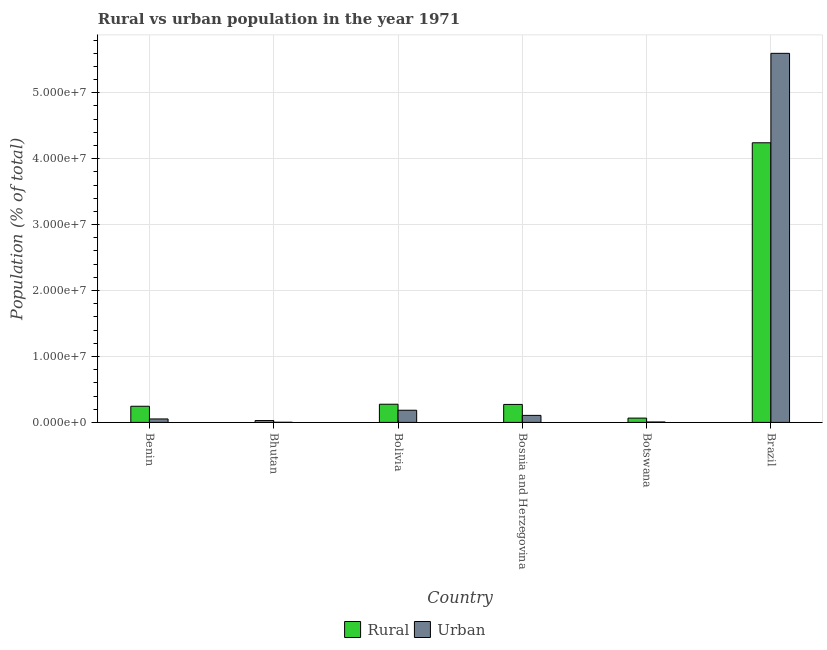How many groups of bars are there?
Your answer should be very brief. 6. Are the number of bars per tick equal to the number of legend labels?
Your response must be concise. Yes. Are the number of bars on each tick of the X-axis equal?
Keep it short and to the point. Yes. How many bars are there on the 1st tick from the left?
Offer a terse response. 2. How many bars are there on the 2nd tick from the right?
Keep it short and to the point. 2. What is the label of the 2nd group of bars from the left?
Provide a short and direct response. Bhutan. In how many cases, is the number of bars for a given country not equal to the number of legend labels?
Offer a very short reply. 0. What is the rural population density in Bosnia and Herzegovina?
Make the answer very short. 2.73e+06. Across all countries, what is the maximum rural population density?
Offer a terse response. 4.24e+07. Across all countries, what is the minimum rural population density?
Your answer should be compact. 2.82e+05. In which country was the urban population density minimum?
Ensure brevity in your answer.  Bhutan. What is the total urban population density in the graph?
Your answer should be compact. 5.95e+07. What is the difference between the rural population density in Benin and that in Bhutan?
Your response must be concise. 2.17e+06. What is the difference between the rural population density in Bhutan and the urban population density in Bosnia and Herzegovina?
Your response must be concise. -7.83e+05. What is the average rural population density per country?
Offer a terse response. 8.55e+06. What is the difference between the rural population density and urban population density in Bhutan?
Offer a very short reply. 2.63e+05. What is the ratio of the urban population density in Benin to that in Botswana?
Your answer should be compact. 8.14. Is the difference between the rural population density in Botswana and Brazil greater than the difference between the urban population density in Botswana and Brazil?
Offer a very short reply. Yes. What is the difference between the highest and the second highest urban population density?
Give a very brief answer. 5.41e+07. What is the difference between the highest and the lowest rural population density?
Ensure brevity in your answer.  4.21e+07. In how many countries, is the rural population density greater than the average rural population density taken over all countries?
Offer a terse response. 1. Is the sum of the urban population density in Bosnia and Herzegovina and Botswana greater than the maximum rural population density across all countries?
Provide a succinct answer. No. What does the 1st bar from the left in Brazil represents?
Make the answer very short. Rural. What does the 2nd bar from the right in Bosnia and Herzegovina represents?
Your answer should be very brief. Rural. How many bars are there?
Offer a very short reply. 12. Are all the bars in the graph horizontal?
Provide a succinct answer. No. How many countries are there in the graph?
Your answer should be compact. 6. What is the difference between two consecutive major ticks on the Y-axis?
Give a very brief answer. 1.00e+07. How many legend labels are there?
Keep it short and to the point. 2. How are the legend labels stacked?
Keep it short and to the point. Horizontal. What is the title of the graph?
Offer a terse response. Rural vs urban population in the year 1971. What is the label or title of the X-axis?
Your answer should be very brief. Country. What is the label or title of the Y-axis?
Offer a terse response. Population (% of total). What is the Population (% of total) in Rural in Benin?
Make the answer very short. 2.45e+06. What is the Population (% of total) of Urban in Benin?
Offer a terse response. 5.24e+05. What is the Population (% of total) of Rural in Bhutan?
Provide a short and direct response. 2.82e+05. What is the Population (% of total) of Urban in Bhutan?
Make the answer very short. 1.93e+04. What is the Population (% of total) in Rural in Bolivia?
Your answer should be compact. 2.76e+06. What is the Population (% of total) in Urban in Bolivia?
Make the answer very short. 1.84e+06. What is the Population (% of total) of Rural in Bosnia and Herzegovina?
Offer a very short reply. 2.73e+06. What is the Population (% of total) in Urban in Bosnia and Herzegovina?
Your answer should be compact. 1.07e+06. What is the Population (% of total) of Rural in Botswana?
Your response must be concise. 6.51e+05. What is the Population (% of total) in Urban in Botswana?
Your response must be concise. 6.44e+04. What is the Population (% of total) of Rural in Brazil?
Offer a very short reply. 4.24e+07. What is the Population (% of total) of Urban in Brazil?
Your response must be concise. 5.60e+07. Across all countries, what is the maximum Population (% of total) of Rural?
Give a very brief answer. 4.24e+07. Across all countries, what is the maximum Population (% of total) in Urban?
Provide a short and direct response. 5.60e+07. Across all countries, what is the minimum Population (% of total) in Rural?
Offer a terse response. 2.82e+05. Across all countries, what is the minimum Population (% of total) in Urban?
Provide a short and direct response. 1.93e+04. What is the total Population (% of total) of Rural in the graph?
Give a very brief answer. 5.13e+07. What is the total Population (% of total) in Urban in the graph?
Provide a short and direct response. 5.95e+07. What is the difference between the Population (% of total) in Rural in Benin and that in Bhutan?
Provide a succinct answer. 2.17e+06. What is the difference between the Population (% of total) of Urban in Benin and that in Bhutan?
Your answer should be very brief. 5.05e+05. What is the difference between the Population (% of total) of Rural in Benin and that in Bolivia?
Your response must be concise. -3.09e+05. What is the difference between the Population (% of total) of Urban in Benin and that in Bolivia?
Give a very brief answer. -1.32e+06. What is the difference between the Population (% of total) of Rural in Benin and that in Bosnia and Herzegovina?
Your answer should be very brief. -2.78e+05. What is the difference between the Population (% of total) in Urban in Benin and that in Bosnia and Herzegovina?
Ensure brevity in your answer.  -5.41e+05. What is the difference between the Population (% of total) in Rural in Benin and that in Botswana?
Keep it short and to the point. 1.80e+06. What is the difference between the Population (% of total) of Urban in Benin and that in Botswana?
Your answer should be very brief. 4.60e+05. What is the difference between the Population (% of total) in Rural in Benin and that in Brazil?
Make the answer very short. -4.00e+07. What is the difference between the Population (% of total) of Urban in Benin and that in Brazil?
Give a very brief answer. -5.55e+07. What is the difference between the Population (% of total) of Rural in Bhutan and that in Bolivia?
Your response must be concise. -2.47e+06. What is the difference between the Population (% of total) in Urban in Bhutan and that in Bolivia?
Your answer should be compact. -1.82e+06. What is the difference between the Population (% of total) in Rural in Bhutan and that in Bosnia and Herzegovina?
Provide a short and direct response. -2.44e+06. What is the difference between the Population (% of total) in Urban in Bhutan and that in Bosnia and Herzegovina?
Offer a terse response. -1.05e+06. What is the difference between the Population (% of total) in Rural in Bhutan and that in Botswana?
Provide a succinct answer. -3.69e+05. What is the difference between the Population (% of total) of Urban in Bhutan and that in Botswana?
Your answer should be very brief. -4.51e+04. What is the difference between the Population (% of total) of Rural in Bhutan and that in Brazil?
Offer a very short reply. -4.21e+07. What is the difference between the Population (% of total) in Urban in Bhutan and that in Brazil?
Your response must be concise. -5.60e+07. What is the difference between the Population (% of total) in Rural in Bolivia and that in Bosnia and Herzegovina?
Give a very brief answer. 3.07e+04. What is the difference between the Population (% of total) in Urban in Bolivia and that in Bosnia and Herzegovina?
Make the answer very short. 7.79e+05. What is the difference between the Population (% of total) in Rural in Bolivia and that in Botswana?
Give a very brief answer. 2.11e+06. What is the difference between the Population (% of total) of Urban in Bolivia and that in Botswana?
Your answer should be very brief. 1.78e+06. What is the difference between the Population (% of total) of Rural in Bolivia and that in Brazil?
Provide a short and direct response. -3.97e+07. What is the difference between the Population (% of total) of Urban in Bolivia and that in Brazil?
Provide a succinct answer. -5.41e+07. What is the difference between the Population (% of total) in Rural in Bosnia and Herzegovina and that in Botswana?
Offer a terse response. 2.07e+06. What is the difference between the Population (% of total) in Urban in Bosnia and Herzegovina and that in Botswana?
Give a very brief answer. 1.00e+06. What is the difference between the Population (% of total) in Rural in Bosnia and Herzegovina and that in Brazil?
Ensure brevity in your answer.  -3.97e+07. What is the difference between the Population (% of total) in Urban in Bosnia and Herzegovina and that in Brazil?
Make the answer very short. -5.49e+07. What is the difference between the Population (% of total) of Rural in Botswana and that in Brazil?
Keep it short and to the point. -4.18e+07. What is the difference between the Population (% of total) of Urban in Botswana and that in Brazil?
Make the answer very short. -5.59e+07. What is the difference between the Population (% of total) in Rural in Benin and the Population (% of total) in Urban in Bhutan?
Your answer should be compact. 2.43e+06. What is the difference between the Population (% of total) of Rural in Benin and the Population (% of total) of Urban in Bolivia?
Give a very brief answer. 6.03e+05. What is the difference between the Population (% of total) in Rural in Benin and the Population (% of total) in Urban in Bosnia and Herzegovina?
Offer a very short reply. 1.38e+06. What is the difference between the Population (% of total) in Rural in Benin and the Population (% of total) in Urban in Botswana?
Give a very brief answer. 2.38e+06. What is the difference between the Population (% of total) of Rural in Benin and the Population (% of total) of Urban in Brazil?
Your answer should be very brief. -5.35e+07. What is the difference between the Population (% of total) of Rural in Bhutan and the Population (% of total) of Urban in Bolivia?
Give a very brief answer. -1.56e+06. What is the difference between the Population (% of total) in Rural in Bhutan and the Population (% of total) in Urban in Bosnia and Herzegovina?
Offer a very short reply. -7.83e+05. What is the difference between the Population (% of total) of Rural in Bhutan and the Population (% of total) of Urban in Botswana?
Offer a very short reply. 2.18e+05. What is the difference between the Population (% of total) in Rural in Bhutan and the Population (% of total) in Urban in Brazil?
Offer a very short reply. -5.57e+07. What is the difference between the Population (% of total) of Rural in Bolivia and the Population (% of total) of Urban in Bosnia and Herzegovina?
Make the answer very short. 1.69e+06. What is the difference between the Population (% of total) of Rural in Bolivia and the Population (% of total) of Urban in Botswana?
Provide a succinct answer. 2.69e+06. What is the difference between the Population (% of total) in Rural in Bolivia and the Population (% of total) in Urban in Brazil?
Your answer should be very brief. -5.32e+07. What is the difference between the Population (% of total) in Rural in Bosnia and Herzegovina and the Population (% of total) in Urban in Botswana?
Ensure brevity in your answer.  2.66e+06. What is the difference between the Population (% of total) of Rural in Bosnia and Herzegovina and the Population (% of total) of Urban in Brazil?
Ensure brevity in your answer.  -5.33e+07. What is the difference between the Population (% of total) of Rural in Botswana and the Population (% of total) of Urban in Brazil?
Keep it short and to the point. -5.53e+07. What is the average Population (% of total) of Rural per country?
Keep it short and to the point. 8.55e+06. What is the average Population (% of total) in Urban per country?
Provide a succinct answer. 9.92e+06. What is the difference between the Population (% of total) of Rural and Population (% of total) of Urban in Benin?
Your response must be concise. 1.92e+06. What is the difference between the Population (% of total) of Rural and Population (% of total) of Urban in Bhutan?
Your answer should be compact. 2.63e+05. What is the difference between the Population (% of total) in Rural and Population (% of total) in Urban in Bolivia?
Ensure brevity in your answer.  9.13e+05. What is the difference between the Population (% of total) of Rural and Population (% of total) of Urban in Bosnia and Herzegovina?
Your answer should be very brief. 1.66e+06. What is the difference between the Population (% of total) in Rural and Population (% of total) in Urban in Botswana?
Provide a short and direct response. 5.87e+05. What is the difference between the Population (% of total) of Rural and Population (% of total) of Urban in Brazil?
Your answer should be compact. -1.36e+07. What is the ratio of the Population (% of total) in Rural in Benin to that in Bhutan?
Ensure brevity in your answer.  8.67. What is the ratio of the Population (% of total) in Urban in Benin to that in Bhutan?
Make the answer very short. 27.11. What is the ratio of the Population (% of total) of Rural in Benin to that in Bolivia?
Your response must be concise. 0.89. What is the ratio of the Population (% of total) in Urban in Benin to that in Bolivia?
Your response must be concise. 0.28. What is the ratio of the Population (% of total) in Rural in Benin to that in Bosnia and Herzegovina?
Give a very brief answer. 0.9. What is the ratio of the Population (% of total) of Urban in Benin to that in Bosnia and Herzegovina?
Offer a terse response. 0.49. What is the ratio of the Population (% of total) in Rural in Benin to that in Botswana?
Ensure brevity in your answer.  3.76. What is the ratio of the Population (% of total) of Urban in Benin to that in Botswana?
Your answer should be compact. 8.14. What is the ratio of the Population (% of total) in Rural in Benin to that in Brazil?
Your answer should be compact. 0.06. What is the ratio of the Population (% of total) in Urban in Benin to that in Brazil?
Ensure brevity in your answer.  0.01. What is the ratio of the Population (% of total) in Rural in Bhutan to that in Bolivia?
Your answer should be compact. 0.1. What is the ratio of the Population (% of total) of Urban in Bhutan to that in Bolivia?
Keep it short and to the point. 0.01. What is the ratio of the Population (% of total) of Rural in Bhutan to that in Bosnia and Herzegovina?
Your answer should be very brief. 0.1. What is the ratio of the Population (% of total) in Urban in Bhutan to that in Bosnia and Herzegovina?
Your answer should be very brief. 0.02. What is the ratio of the Population (% of total) in Rural in Bhutan to that in Botswana?
Your response must be concise. 0.43. What is the ratio of the Population (% of total) in Urban in Bhutan to that in Botswana?
Your response must be concise. 0.3. What is the ratio of the Population (% of total) of Rural in Bhutan to that in Brazil?
Your answer should be compact. 0.01. What is the ratio of the Population (% of total) in Urban in Bhutan to that in Brazil?
Provide a succinct answer. 0. What is the ratio of the Population (% of total) of Rural in Bolivia to that in Bosnia and Herzegovina?
Provide a succinct answer. 1.01. What is the ratio of the Population (% of total) of Urban in Bolivia to that in Bosnia and Herzegovina?
Provide a short and direct response. 1.73. What is the ratio of the Population (% of total) in Rural in Bolivia to that in Botswana?
Make the answer very short. 4.23. What is the ratio of the Population (% of total) of Urban in Bolivia to that in Botswana?
Offer a very short reply. 28.63. What is the ratio of the Population (% of total) of Rural in Bolivia to that in Brazil?
Provide a succinct answer. 0.07. What is the ratio of the Population (% of total) of Urban in Bolivia to that in Brazil?
Your answer should be compact. 0.03. What is the ratio of the Population (% of total) of Rural in Bosnia and Herzegovina to that in Botswana?
Make the answer very short. 4.18. What is the ratio of the Population (% of total) in Urban in Bosnia and Herzegovina to that in Botswana?
Provide a short and direct response. 16.54. What is the ratio of the Population (% of total) in Rural in Bosnia and Herzegovina to that in Brazil?
Your answer should be very brief. 0.06. What is the ratio of the Population (% of total) of Urban in Bosnia and Herzegovina to that in Brazil?
Provide a short and direct response. 0.02. What is the ratio of the Population (% of total) in Rural in Botswana to that in Brazil?
Keep it short and to the point. 0.02. What is the ratio of the Population (% of total) in Urban in Botswana to that in Brazil?
Your response must be concise. 0. What is the difference between the highest and the second highest Population (% of total) in Rural?
Keep it short and to the point. 3.97e+07. What is the difference between the highest and the second highest Population (% of total) of Urban?
Make the answer very short. 5.41e+07. What is the difference between the highest and the lowest Population (% of total) of Rural?
Give a very brief answer. 4.21e+07. What is the difference between the highest and the lowest Population (% of total) in Urban?
Ensure brevity in your answer.  5.60e+07. 